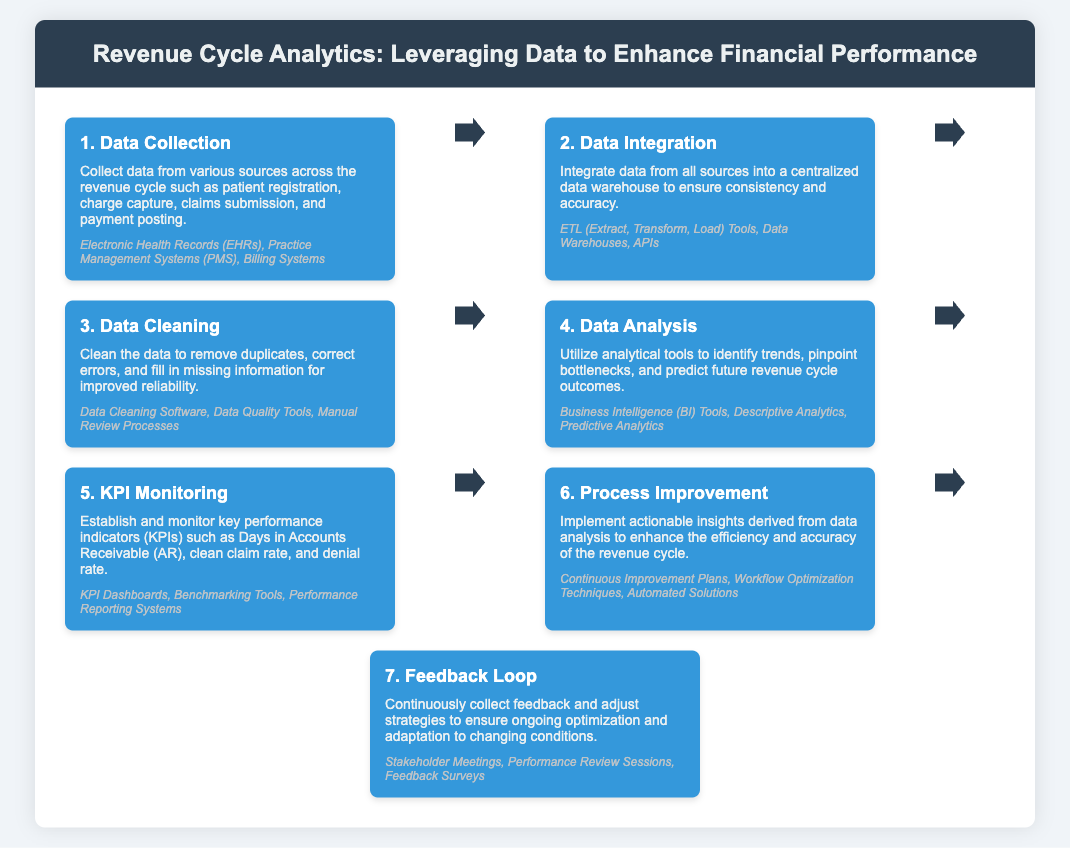What is the first step in the revenue cycle analytics process? The information about the steps indicates that the first step is "Data Collection."
Answer: Data Collection What tools are mentioned for data integration? The document lists "ETL Tools, Data Warehouses, APIs" as tools used for data integration.
Answer: ETL Tools, Data Warehouses, APIs What is one key performance indicator (KPI) monitored in the process? The document mentions "Days in Accounts Receivable" as one of the KPIs established and monitored.
Answer: Days in Accounts Receivable What does the sixth step focus on? The sixth step in the infographic is about "Process Improvement," focusing on enhancing efficiency and accuracy.
Answer: Process Improvement Which tools are suggested for data analysis? The document highlights "Business Intelligence Tools, Descriptive Analytics, Predictive Analytics" as tools for data analysis.
Answer: Business Intelligence Tools, Descriptive Analytics, Predictive Analytics How many steps are detailed in the revenue cycle analytics process? The infographic outlines a total of seven steps in the process.
Answer: Seven steps What is emphasized in the last step of the process? The last step focuses on collecting feedback and adjusting strategies to ensure ongoing optimization.
Answer: Feedback and adjusting strategies 